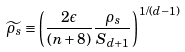Convert formula to latex. <formula><loc_0><loc_0><loc_500><loc_500>\widetilde { \rho _ { s } } \equiv \left ( \frac { 2 \epsilon } { ( n + 8 ) } \frac { \rho _ { s } } { S _ { d + 1 } } \right ) ^ { 1 / ( d - 1 ) }</formula> 